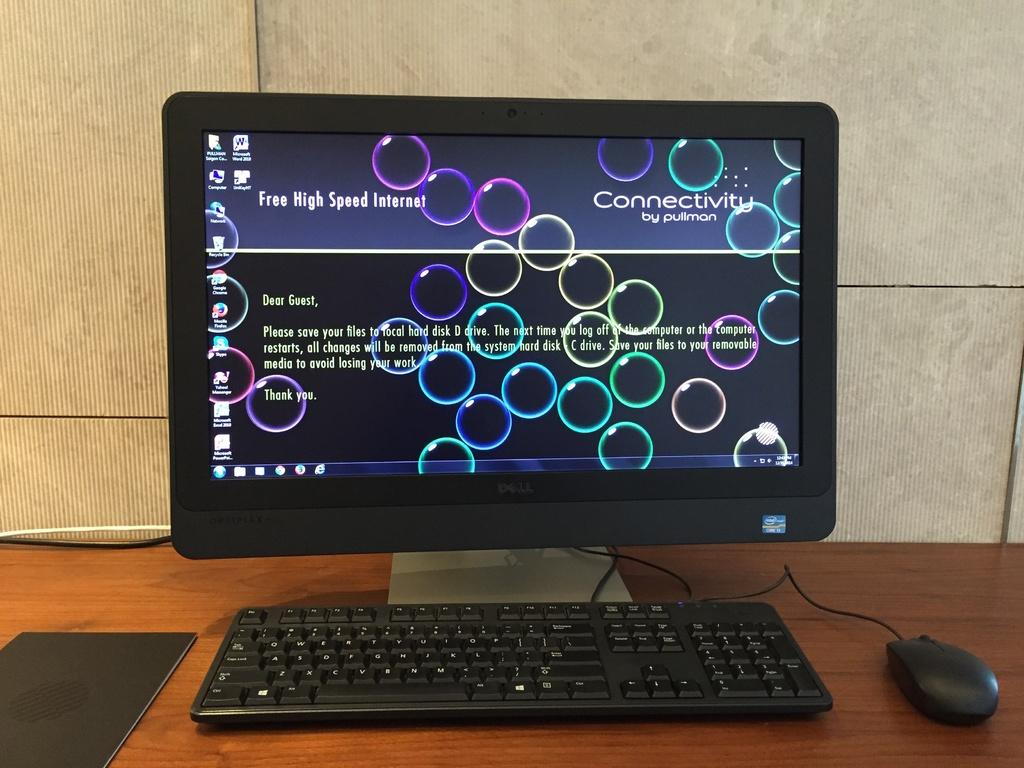<image>
Share a concise interpretation of the image provided. A computer monitor with colorful circles on screen has a message reminding guests to save their files to the D drive. 